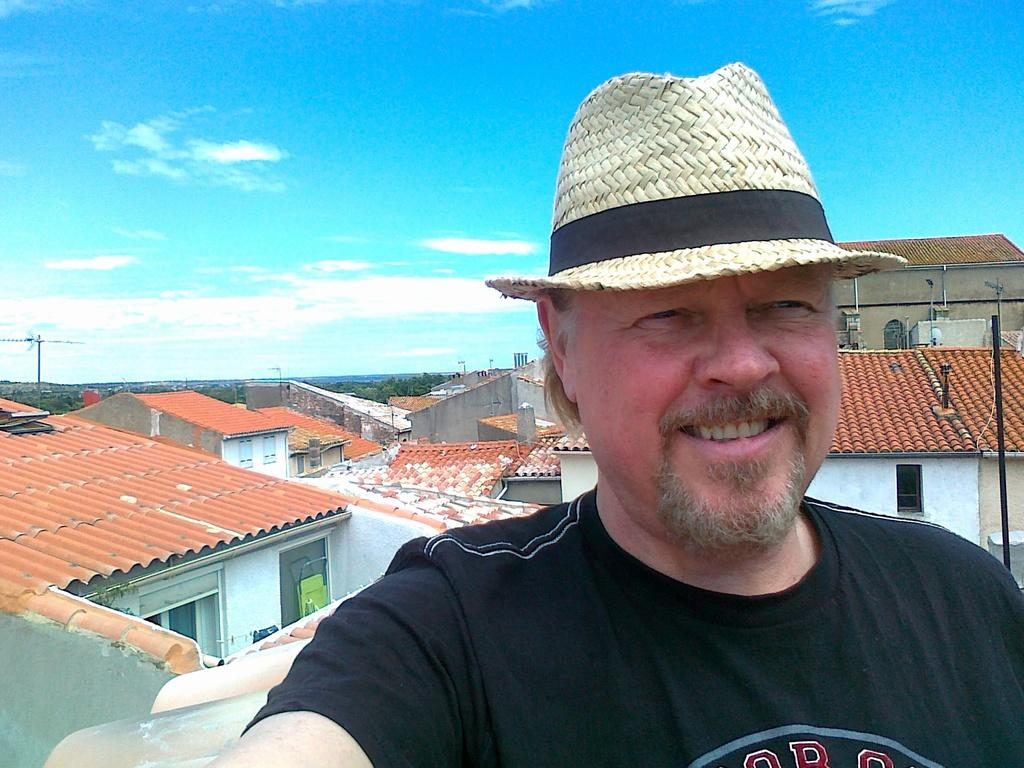What is the main subject of the image? There is a man in the image. What is the man wearing on his head? The man is wearing a cap. What is the man's facial expression? The man is smiling. What can be seen in the background of the image? There are poles, houses, and trees visible in the background of the image. What type of crack is visible on the man's face in the image? There is no crack visible on the man's face in the image. What is the man using to sit on in the image? The image does not show the man sitting, so there is no seat present. 